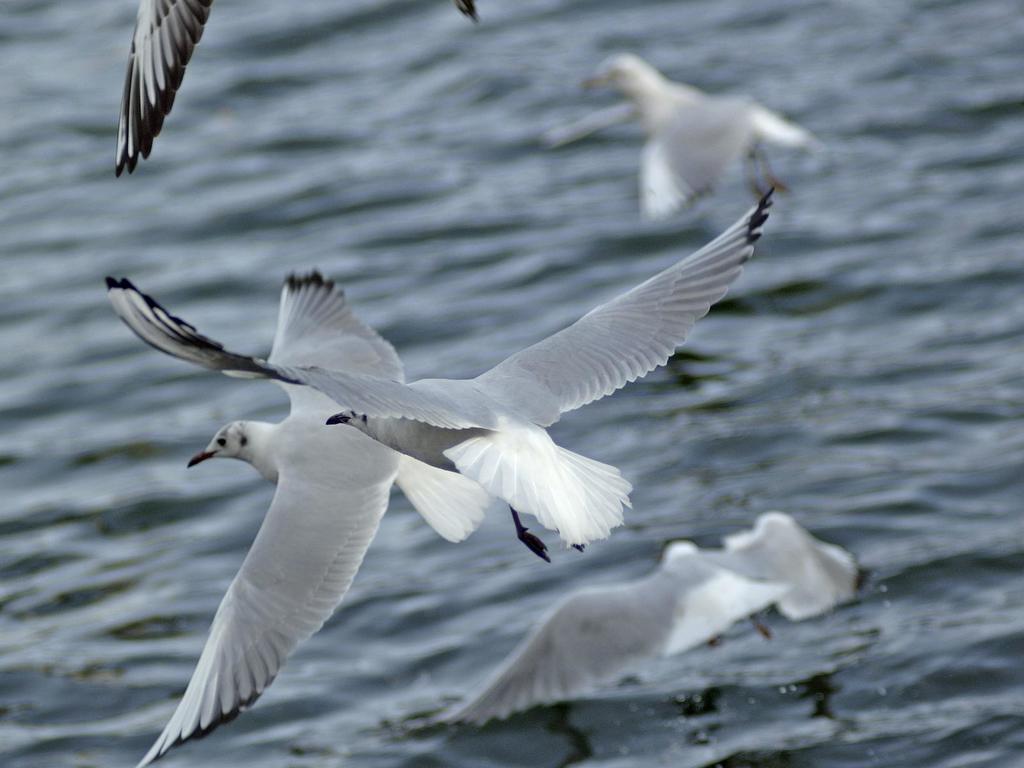In one or two sentences, can you explain what this image depicts? In this image, we can see birds above the water. In the background, image is blurred. 